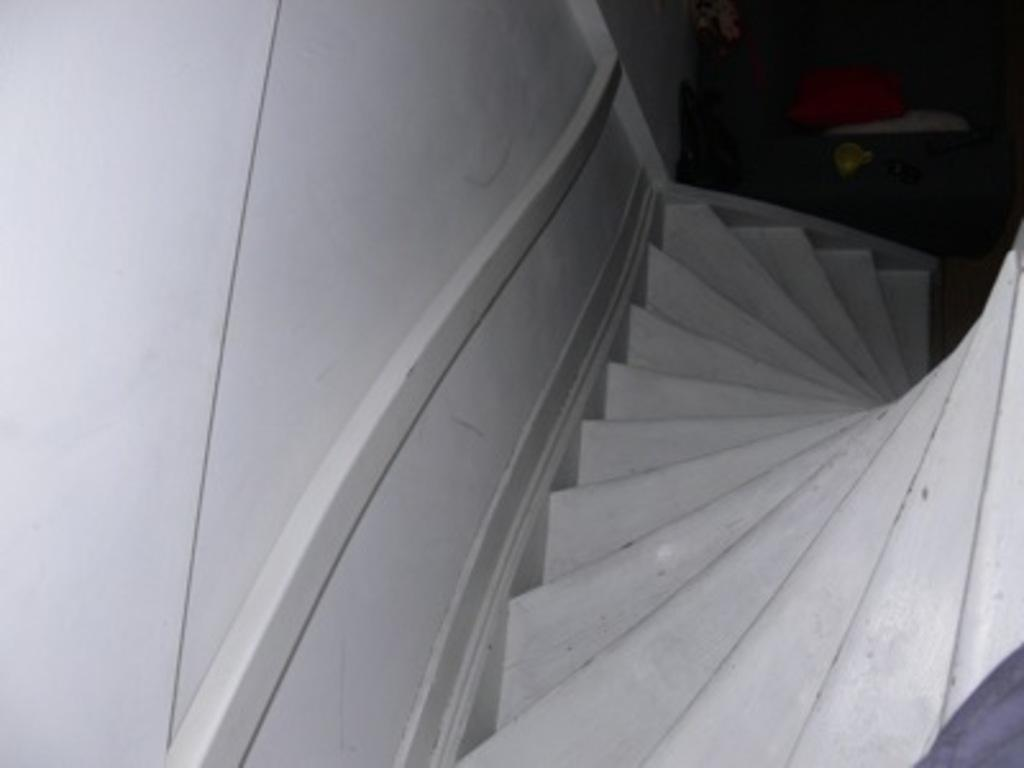What type of structure is present in the image? There are stairs and a wall in the image. What items can be seen on the floor? There is a bag and a cup in the image. What color is the cushion in the image? The cushion in the image is red. What else is visible in the image besides the mentioned items? There are other objects in the image. What part of the room is visible in the image? The floor is visible in the image. How many servants are visible in the image? There are no servants present in the image. Can you see a giraffe in the image? There is no giraffe present in the image. 